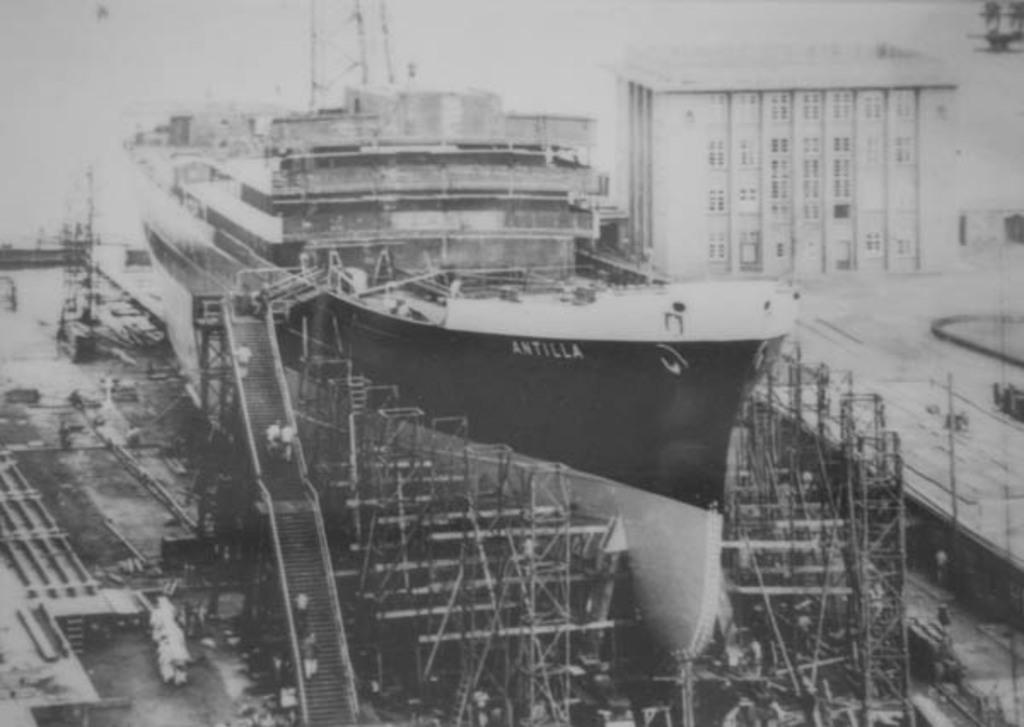<image>
Provide a brief description of the given image. A ship, called the Antilla, is under construction. 